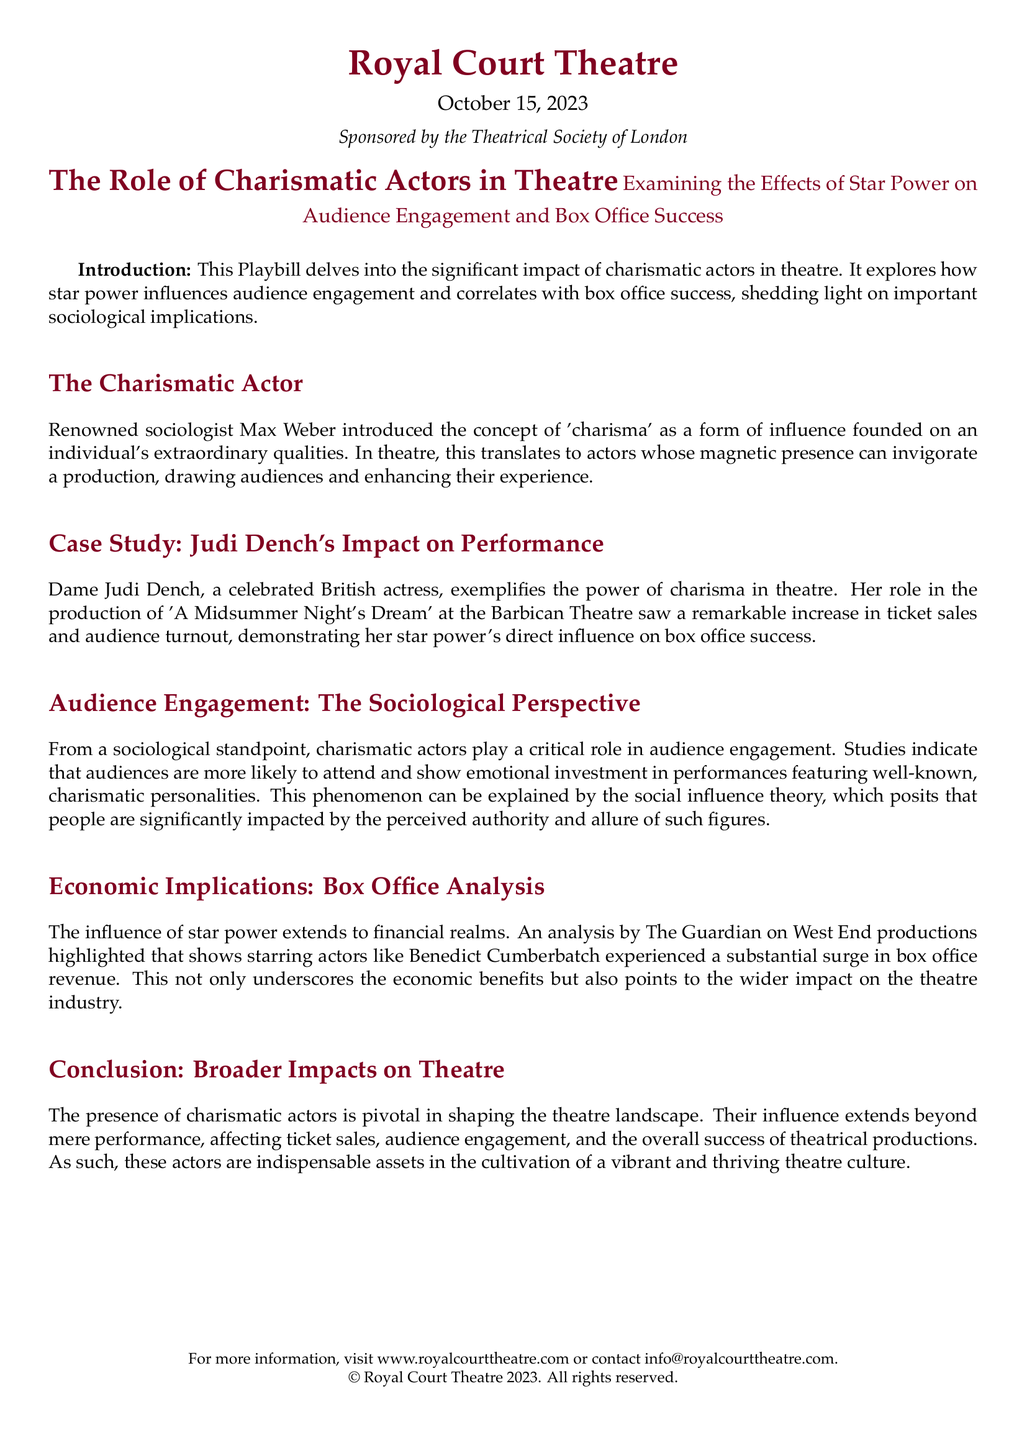What is the date of the Playbill? The date provided in the Playbill is October 15, 2023.
Answer: October 15, 2023 Who is the main focus of the Playbill? The title indicates that the focus is on charismatic actors in theatre and their influence.
Answer: Charismatic actors What case study is mentioned in the Playbill? The Playbill includes a case study on Dame Judi Dench's impact on performance.
Answer: Judi Dench's Impact on Performance Which sociological theory is referenced in the document? The document mentions the social influence theory in relation to audience engagement.
Answer: Social influence theory What notable example of a star's impact is highlighted in the box office analysis? The analysis specifies that shows starring Benedict Cumberbatch saw a surge in box office revenue.
Answer: Benedict Cumberbatch What type of theatre is the Royal Court Theatre identified as sponsoring this document? The Royal Court Theatre is identified as a sponsor in the document.
Answer: Theatre What is the primary subject of the conclusion in the Playbill? The conclusion discusses the broader impacts of charismatic actors on the theatre landscape.
Answer: Broader impacts on theatre What does the introduction emphasize about charismatic actors? The introduction highlights their significant impact on audience engagement and box office success.
Answer: Impact on audience engagement and box office success 